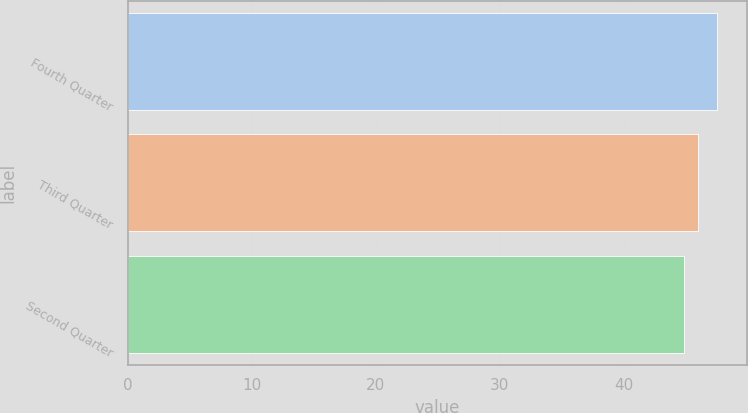Convert chart to OTSL. <chart><loc_0><loc_0><loc_500><loc_500><bar_chart><fcel>Fourth Quarter<fcel>Third Quarter<fcel>Second Quarter<nl><fcel>47.58<fcel>45.98<fcel>44.86<nl></chart> 